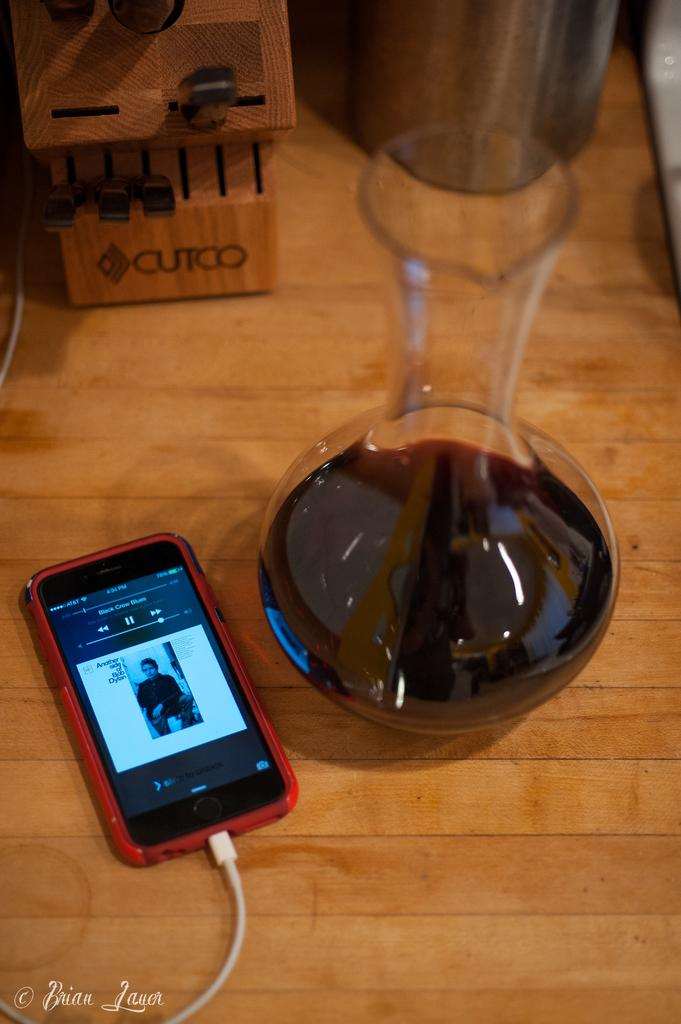<image>
Create a compact narrative representing the image presented. A phone with Black Crows Blues song on playscreen sitting next to wine caref. 